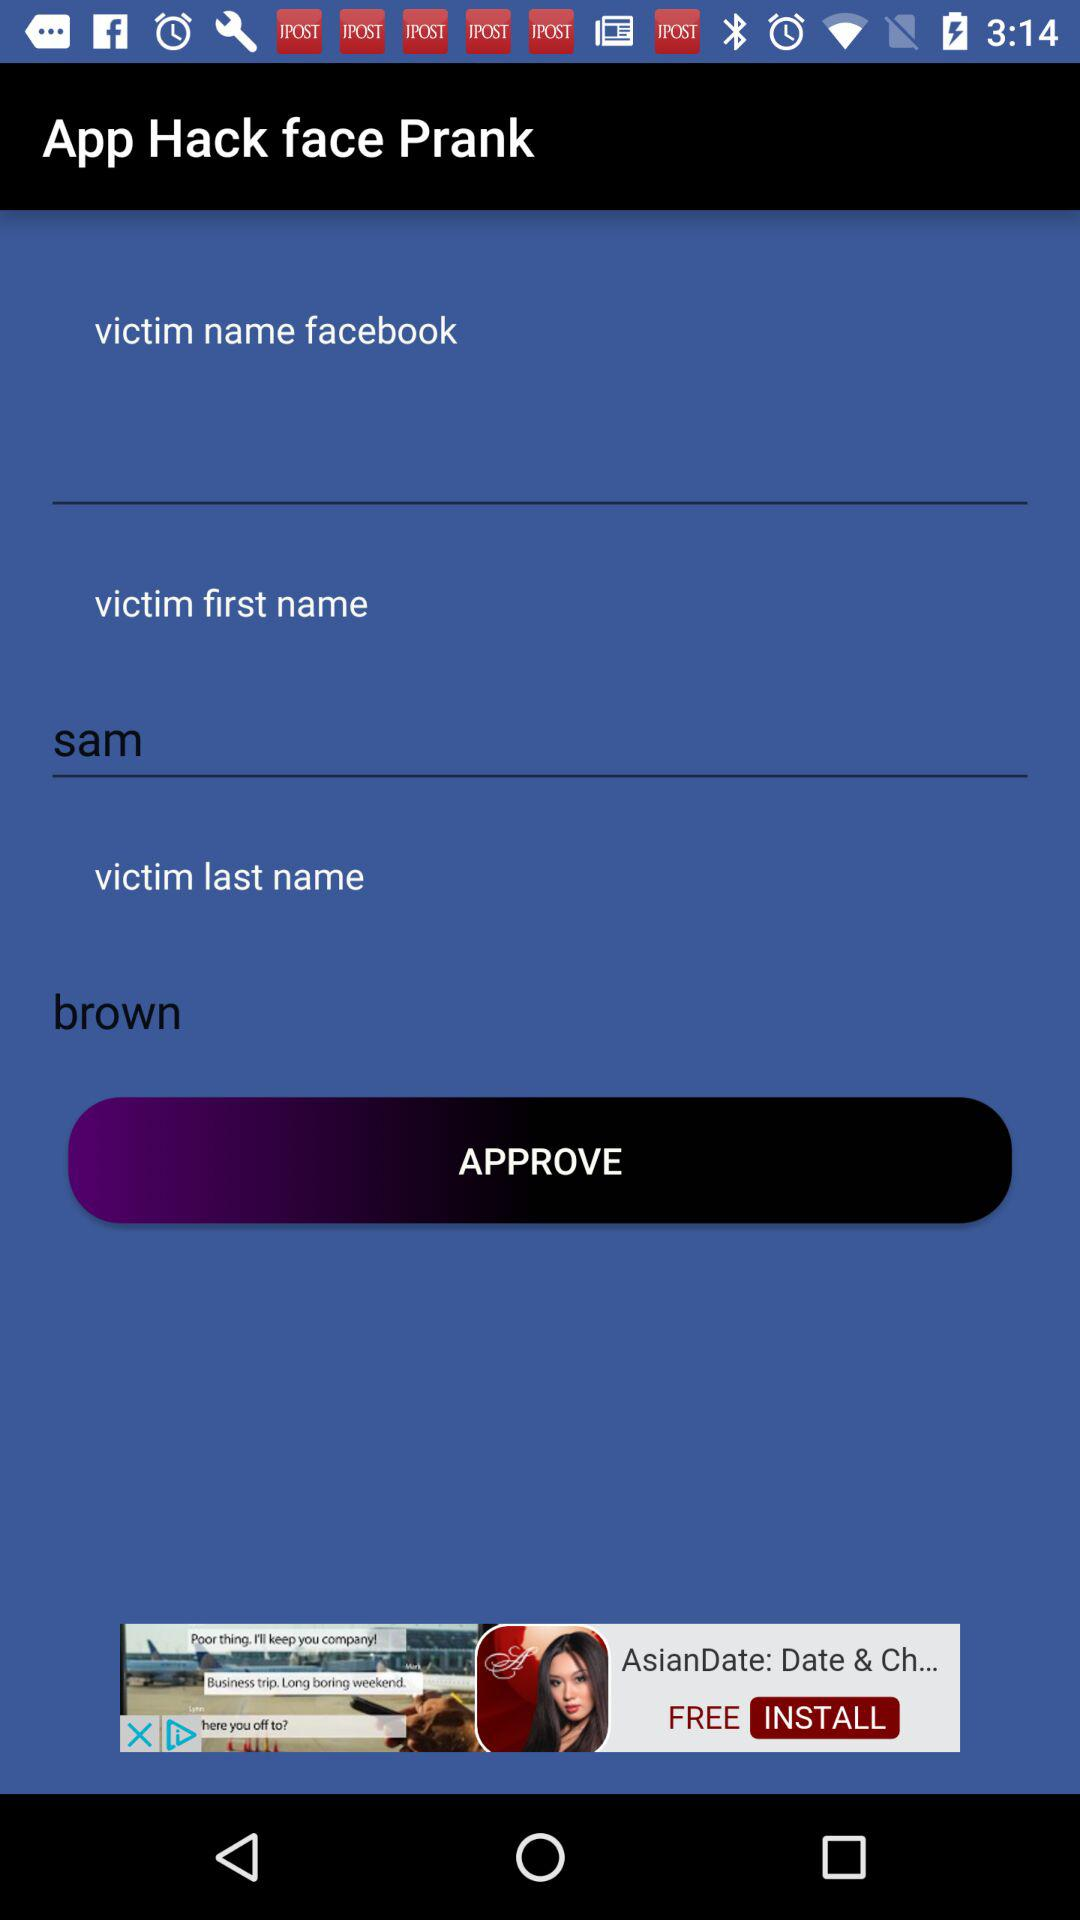What is the app name? The app name is "Hack face Prank". 